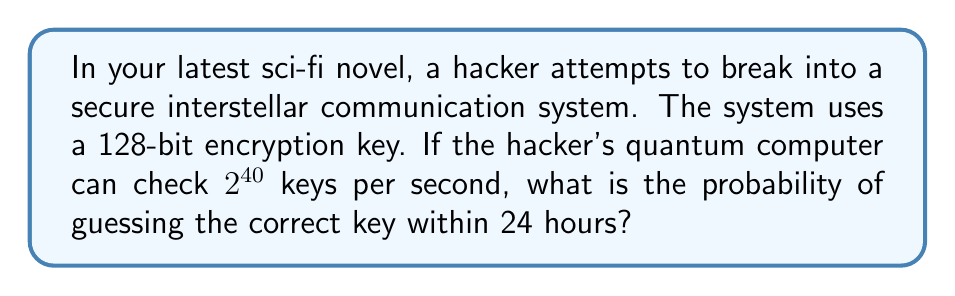Show me your answer to this math problem. Let's approach this step-by-step:

1) First, calculate the total number of possible 128-bit keys:
   $N = 2^{128}$

2) Calculate how many keys the hacker can check in 24 hours:
   24 hours = 86,400 seconds
   Keys checked per second = $2^{40}$
   Keys checked in 24 hours = $86400 \times 2^{40}$

3) The probability of success is the number of keys checked divided by the total number of possible keys:

   $P(\text{success}) = \frac{\text{Keys checked}}{\text{Total possible keys}}$

   $P(\text{success}) = \frac{86400 \times 2^{40}}{2^{128}}$

4) Simplify:
   $P(\text{success}) = 86400 \times 2^{40-128} = 86400 \times 2^{-88}$

5) Calculate:
   $P(\text{success}) \approx 2.98 \times 10^{-22}$

This extremely low probability demonstrates the strength of 128-bit encryption against brute-force attacks, even with a powerful quantum computer.
Answer: $2.98 \times 10^{-22}$ 